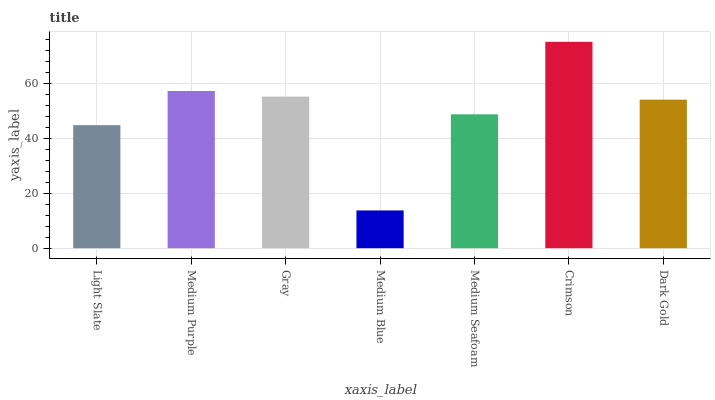Is Medium Blue the minimum?
Answer yes or no. Yes. Is Crimson the maximum?
Answer yes or no. Yes. Is Medium Purple the minimum?
Answer yes or no. No. Is Medium Purple the maximum?
Answer yes or no. No. Is Medium Purple greater than Light Slate?
Answer yes or no. Yes. Is Light Slate less than Medium Purple?
Answer yes or no. Yes. Is Light Slate greater than Medium Purple?
Answer yes or no. No. Is Medium Purple less than Light Slate?
Answer yes or no. No. Is Dark Gold the high median?
Answer yes or no. Yes. Is Dark Gold the low median?
Answer yes or no. Yes. Is Medium Blue the high median?
Answer yes or no. No. Is Medium Blue the low median?
Answer yes or no. No. 